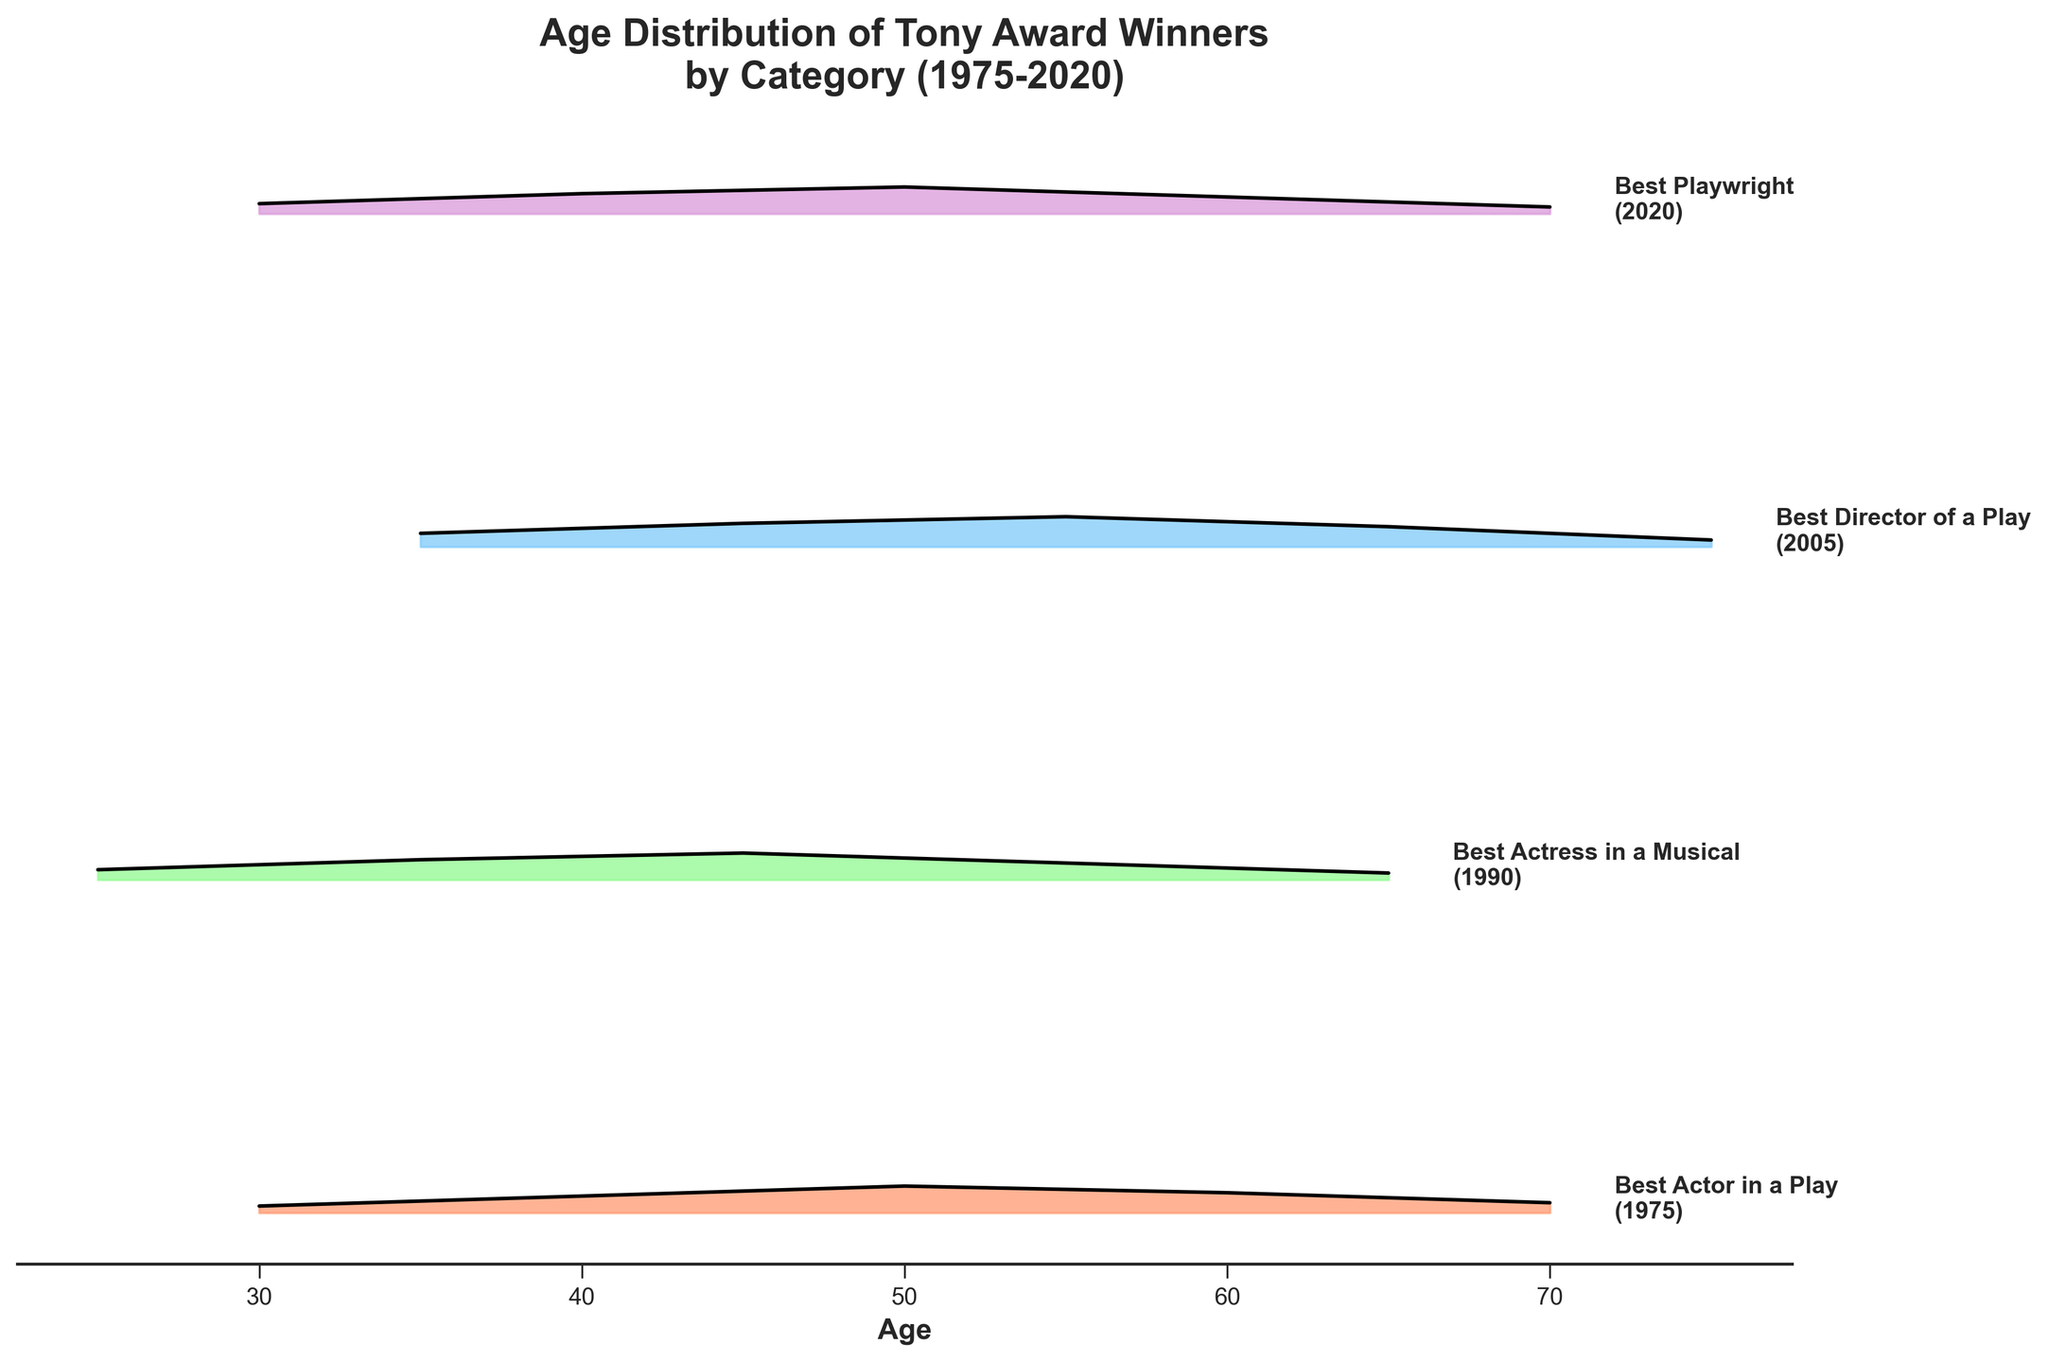Who has the oldest age distribution among the categories? To find the category with the oldest age distribution, look at the rightmost end of the ridgeline plots. “Best Director of a Play” has data points extending up to the age of 75.
Answer: Best Director of a Play Which category tends to have the youngest winners based on the plot? By examining the starting points of the ridgelines, note that “Best Actress in a Musical” starts from age 25, younger than other categories.
Answer: Best Actress in a Musical What is the most common age of winners in the Best Playwright category? To determine the most common age, observe the peak density for the Best Playwright ridgeline. The peak density occurs at age 50.
Answer: 50 Compare the age densities of "Best Actor in a Play" in 1975 and "Best Playwright" in 2020. Which category has a higher density for age 50? By analyzing the ridgeline plot, note the density values at age 50 for each category. "Best Actor in a Play" has a density of 0.08, while "Best Playwright" also peaks at 0.08 at age 50. Thus, both categories have an equal density at age 50.
Answer: Equal Which category has a more diverse spread of ages, Best Actor in a Play or Best Actress in a Musical? Examine the width of the ridgelines. “Best Actor in a Play” spans ages 30 to 70, whereas “Best Actress in a Musical” spans ages 25 to 65. A wider range indicates a more diverse age spread.
Answer: Best Actor in a Play Which year has the highest density value for any category? To find the highest density value, compare peaks of all ridgelines. The highest density of 0.09 is found in the "Best Director of a Play" category in 2005.
Answer: 2005 On average, do Tony Award winners in the analyzed categories tend to be younger or older? Assess the central tendency of the ridgelines for all categories. Most categories peak around 40-50, indicating that winners tend to be middle-aged.
Answer: Middle-aged Between "Best Actress in a Musical" and "Best Director of a Play," which category shows a higher density at age 55? Review the density values at age 55 for both categories. “Best Actress in a Musical” has a density of 0.05 at age 55, whereas “Best Director of a Play” has a density of 0.09 at age 55.
Answer: Best Director of a Play Which category's ridgeline plot extends beyond age 70, and what does this indicate about the winners? The ridgeline for "Best Director of a Play" extends beyond age 70, implying that winners in this category include older individuals.
Answer: Best Director of a Play 